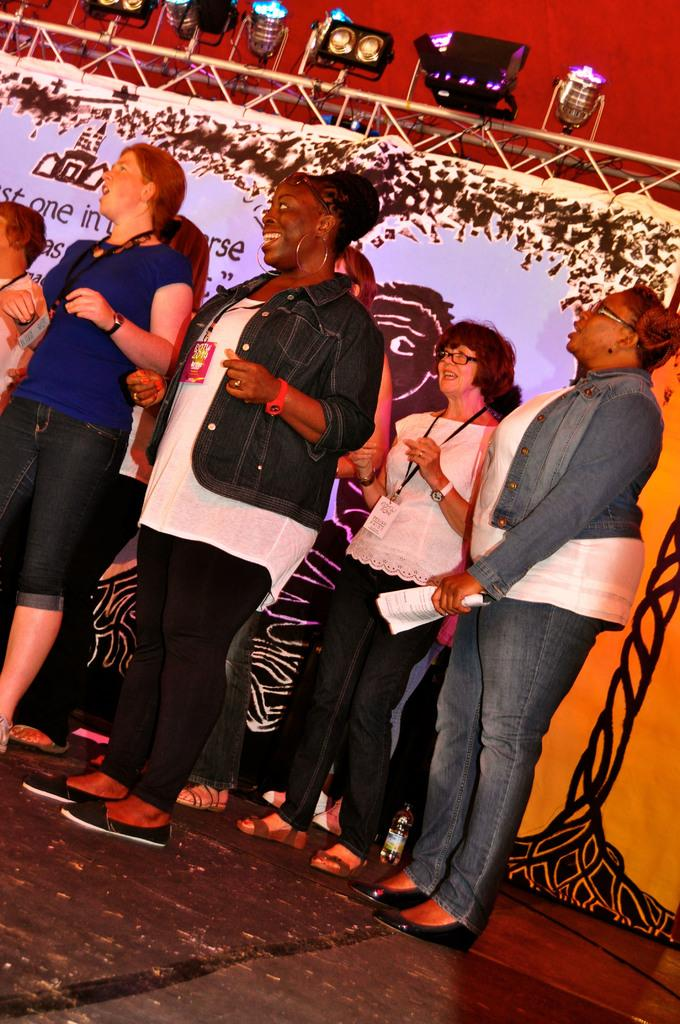What is happening at the bottom of the image? There are many people standing on a dais at the bottom of the image. What can be seen in the background of the image? There is a banner, a stand, and lights in the background of the image. What might be the purpose of the banner in the image? The banner in the background could be used for advertising or conveying a message. What is the position of the stand in the image? The stand is in the background of the image. What type of lawyer is depicted on the train in the image? There is no lawyer or train present in the image. How many pockets are visible on the people standing on the dais? The number of pockets on the people standing on the dais cannot be determined from the image. 